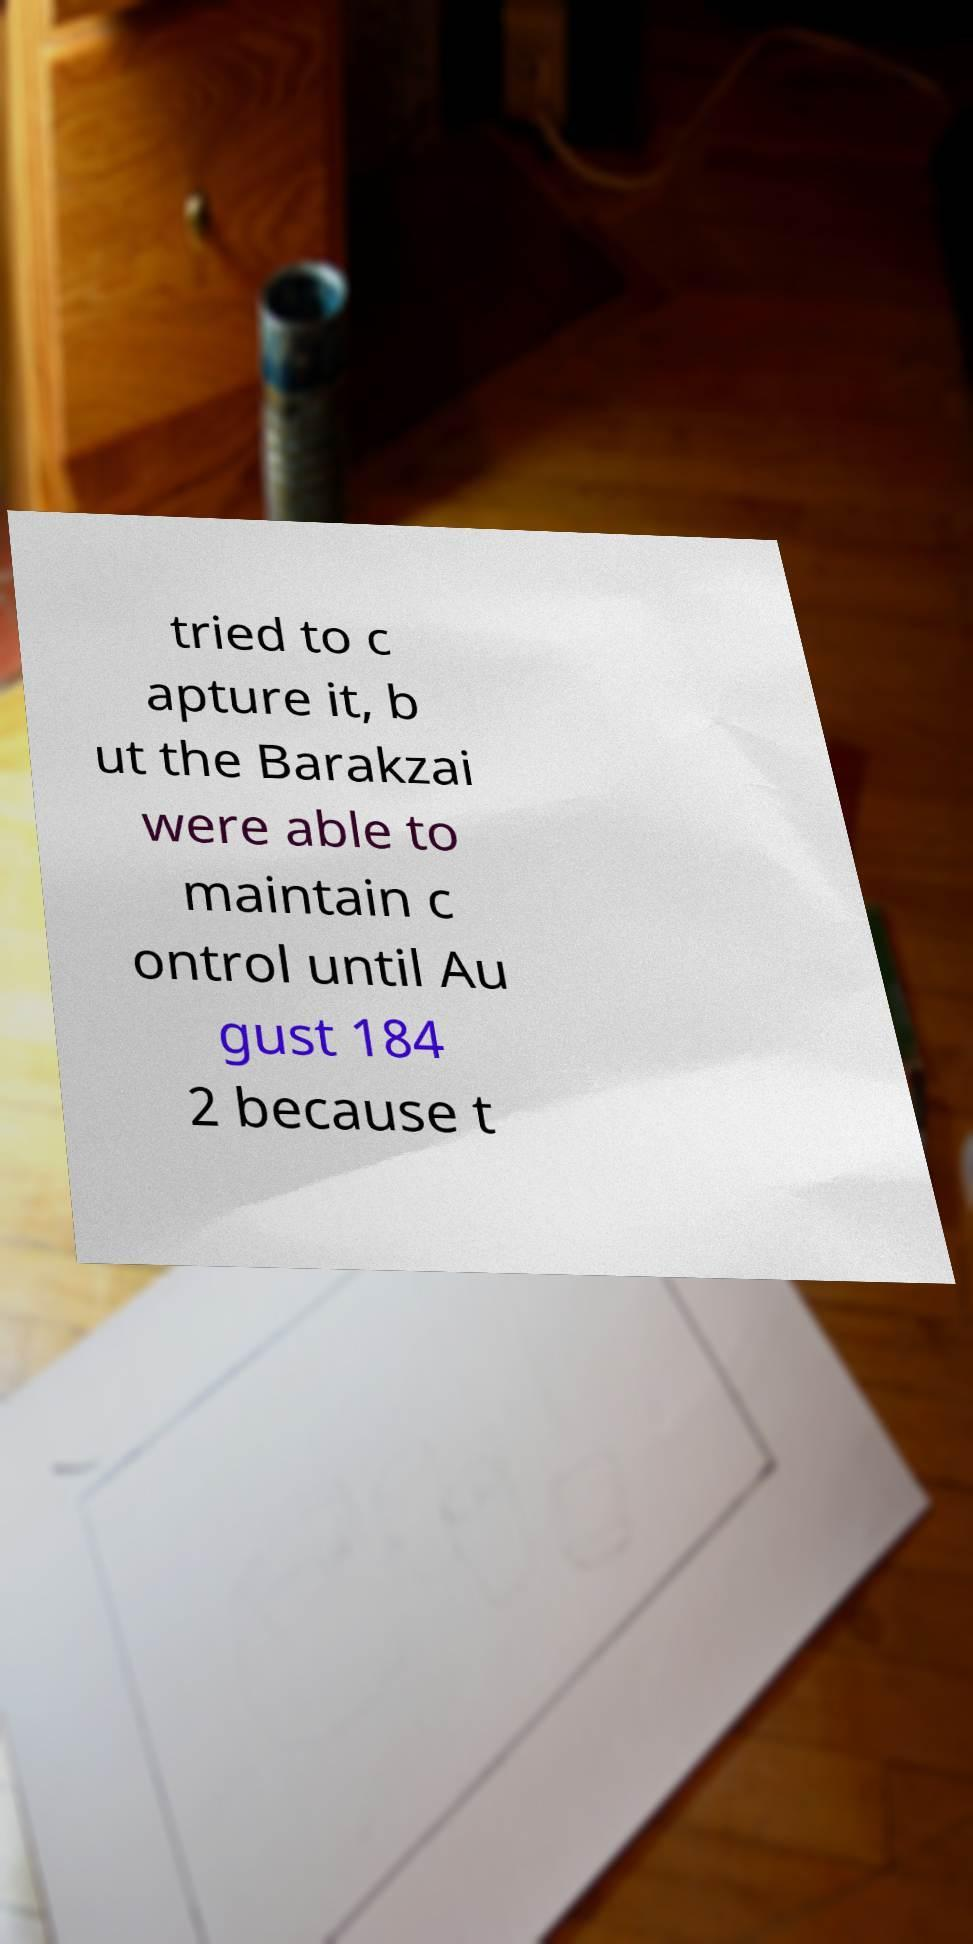There's text embedded in this image that I need extracted. Can you transcribe it verbatim? tried to c apture it, b ut the Barakzai were able to maintain c ontrol until Au gust 184 2 because t 